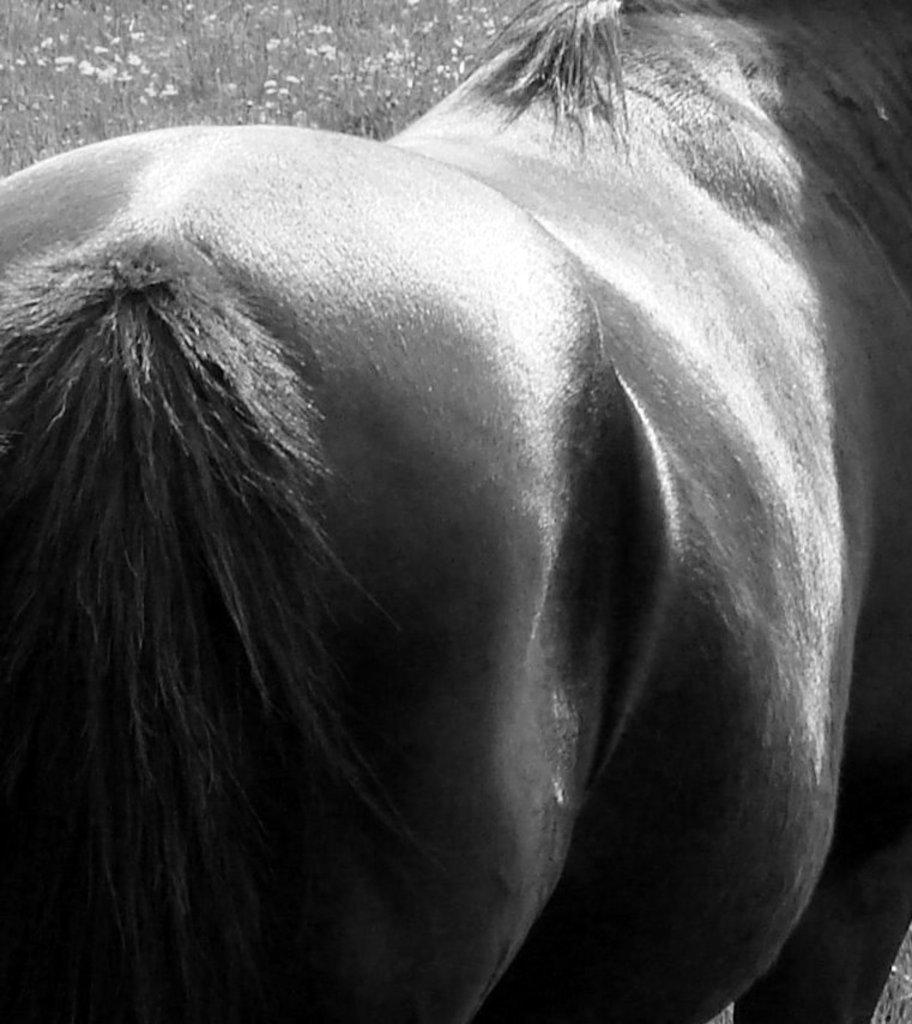What type of animal is standing in the image? The specific type of animal cannot be determined from the provided facts. What can be seen in the background of the image? There are plants with flowers in the background of the image. What type of stamp can be seen on the tent in the image? There is no tent or stamp present in the image. 